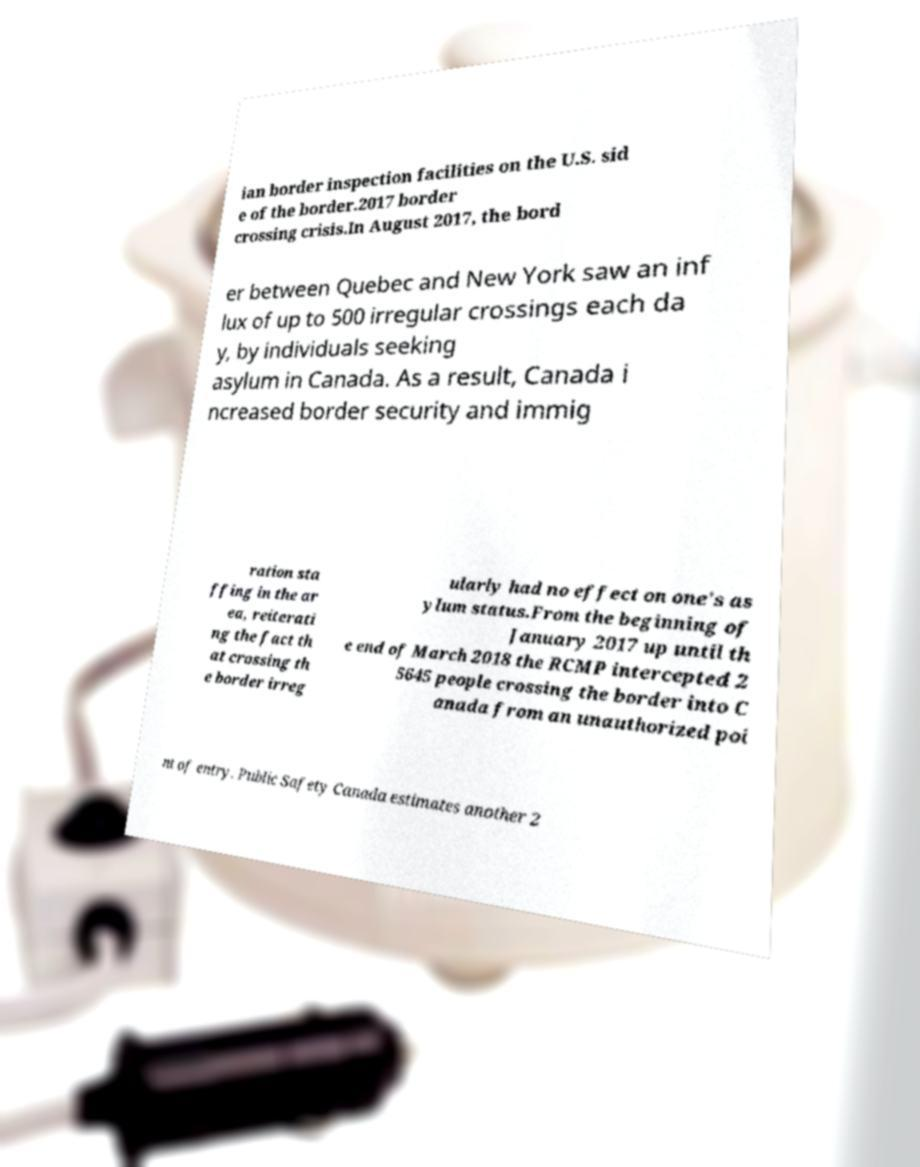Could you assist in decoding the text presented in this image and type it out clearly? ian border inspection facilities on the U.S. sid e of the border.2017 border crossing crisis.In August 2017, the bord er between Quebec and New York saw an inf lux of up to 500 irregular crossings each da y, by individuals seeking asylum in Canada. As a result, Canada i ncreased border security and immig ration sta ffing in the ar ea, reiterati ng the fact th at crossing th e border irreg ularly had no effect on one's as ylum status.From the beginning of January 2017 up until th e end of March 2018 the RCMP intercepted 2 5645 people crossing the border into C anada from an unauthorized poi nt of entry. Public Safety Canada estimates another 2 